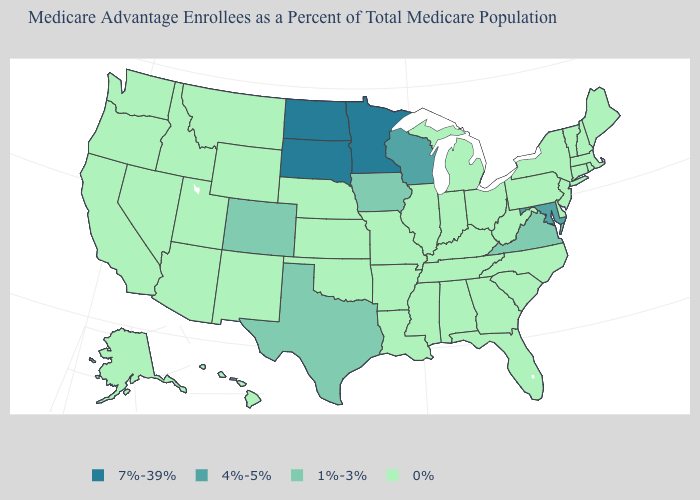Is the legend a continuous bar?
Keep it brief. No. Name the states that have a value in the range 1%-3%?
Be succinct. Colorado, Iowa, Texas, Virginia. What is the value of Pennsylvania?
Short answer required. 0%. Which states have the highest value in the USA?
Keep it brief. Minnesota, North Dakota, South Dakota. How many symbols are there in the legend?
Give a very brief answer. 4. Name the states that have a value in the range 0%?
Short answer required. Alaska, Alabama, Arkansas, Arizona, California, Connecticut, Delaware, Florida, Georgia, Hawaii, Idaho, Illinois, Indiana, Kansas, Kentucky, Louisiana, Massachusetts, Maine, Michigan, Missouri, Mississippi, Montana, North Carolina, Nebraska, New Hampshire, New Jersey, New Mexico, Nevada, New York, Ohio, Oklahoma, Oregon, Pennsylvania, Rhode Island, South Carolina, Tennessee, Utah, Vermont, Washington, West Virginia, Wyoming. Does Arkansas have the lowest value in the USA?
Write a very short answer. Yes. What is the value of New Jersey?
Be succinct. 0%. Which states have the lowest value in the West?
Concise answer only. Alaska, Arizona, California, Hawaii, Idaho, Montana, New Mexico, Nevada, Oregon, Utah, Washington, Wyoming. Which states have the lowest value in the USA?
Give a very brief answer. Alaska, Alabama, Arkansas, Arizona, California, Connecticut, Delaware, Florida, Georgia, Hawaii, Idaho, Illinois, Indiana, Kansas, Kentucky, Louisiana, Massachusetts, Maine, Michigan, Missouri, Mississippi, Montana, North Carolina, Nebraska, New Hampshire, New Jersey, New Mexico, Nevada, New York, Ohio, Oklahoma, Oregon, Pennsylvania, Rhode Island, South Carolina, Tennessee, Utah, Vermont, Washington, West Virginia, Wyoming. Does Nebraska have the highest value in the MidWest?
Write a very short answer. No. Among the states that border Arizona , which have the lowest value?
Give a very brief answer. California, New Mexico, Nevada, Utah. Does Nevada have the lowest value in the USA?
Concise answer only. Yes. 